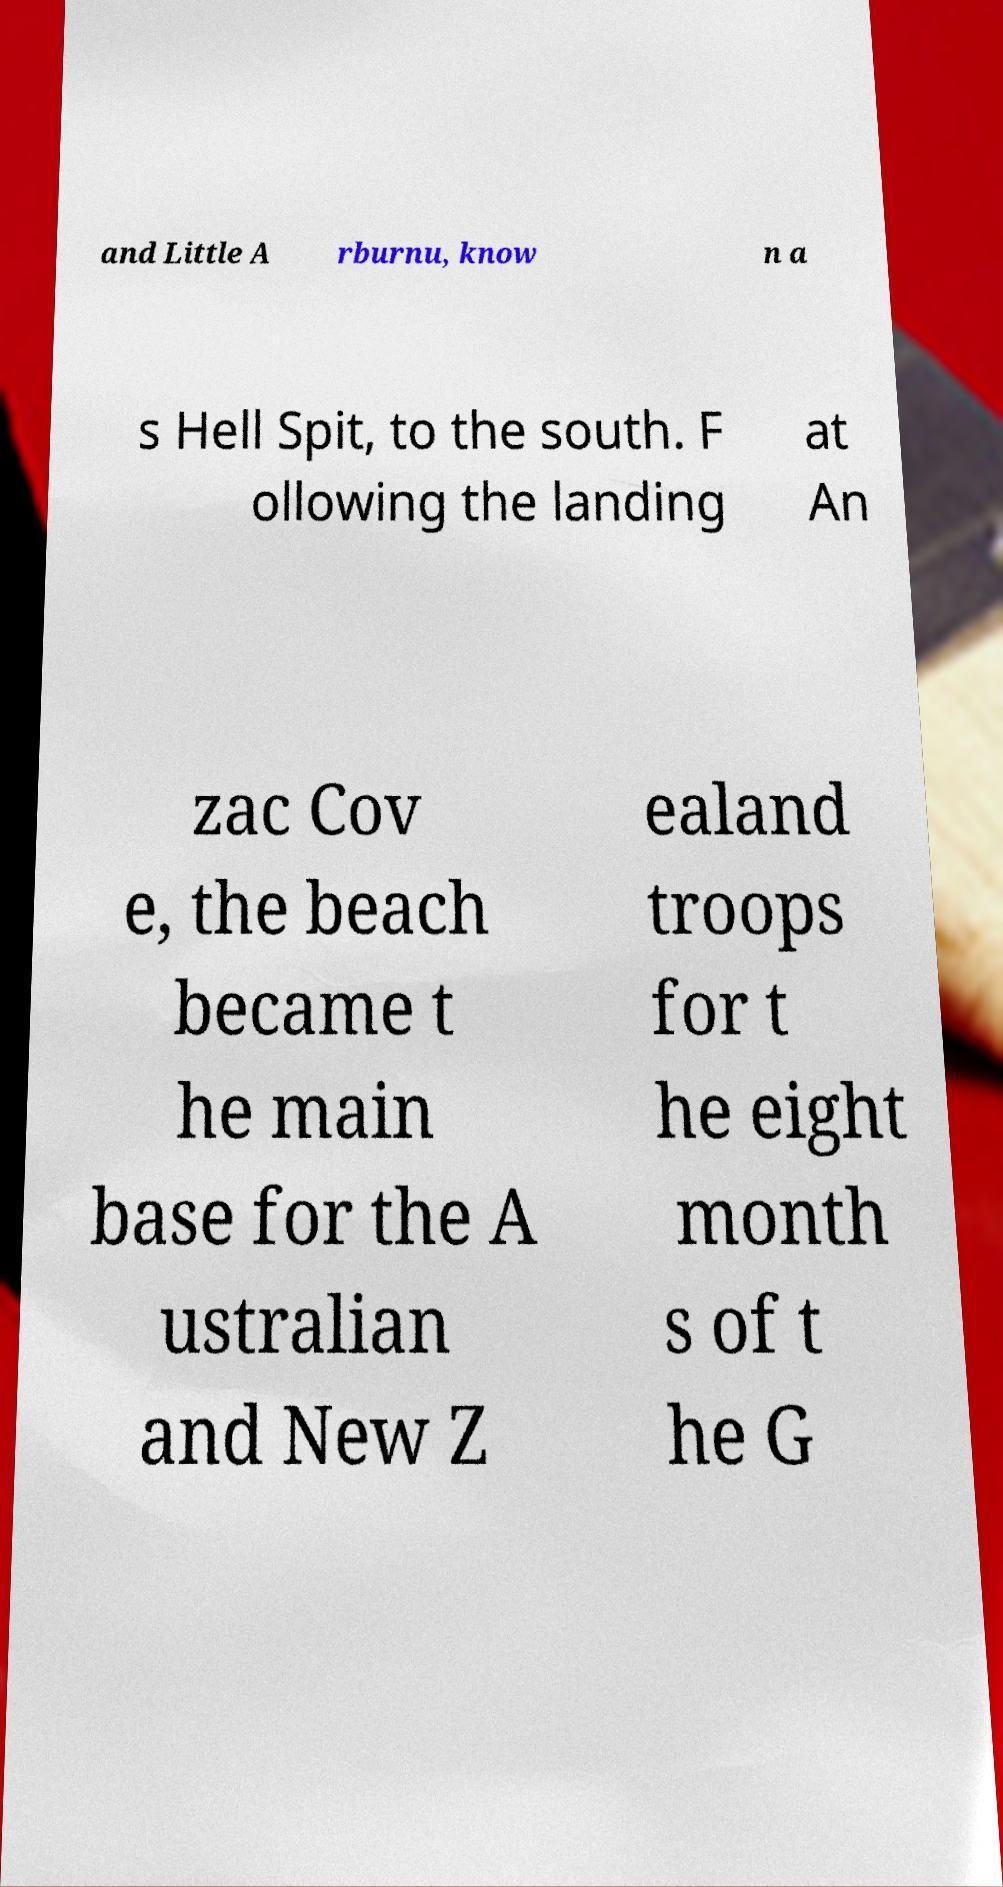For documentation purposes, I need the text within this image transcribed. Could you provide that? and Little A rburnu, know n a s Hell Spit, to the south. F ollowing the landing at An zac Cov e, the beach became t he main base for the A ustralian and New Z ealand troops for t he eight month s of t he G 